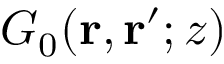Convert formula to latex. <formula><loc_0><loc_0><loc_500><loc_500>G _ { 0 } ( \mathbf r , \mathbf r ^ { \prime } ; z )</formula> 